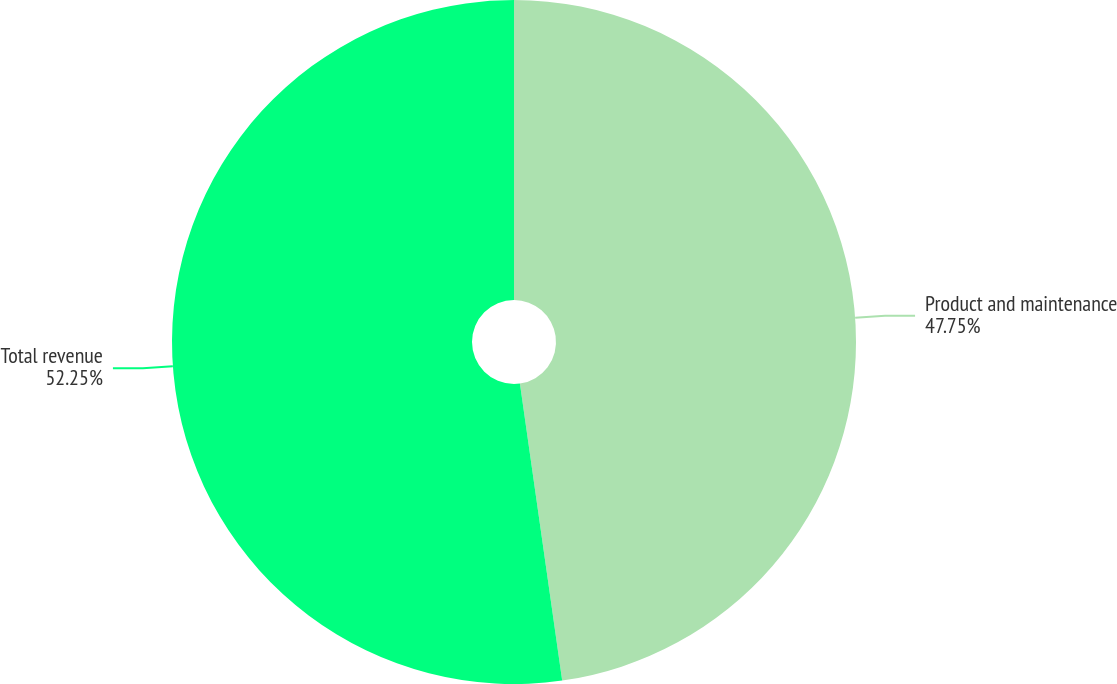Convert chart to OTSL. <chart><loc_0><loc_0><loc_500><loc_500><pie_chart><fcel>Product and maintenance<fcel>Total revenue<nl><fcel>47.75%<fcel>52.25%<nl></chart> 